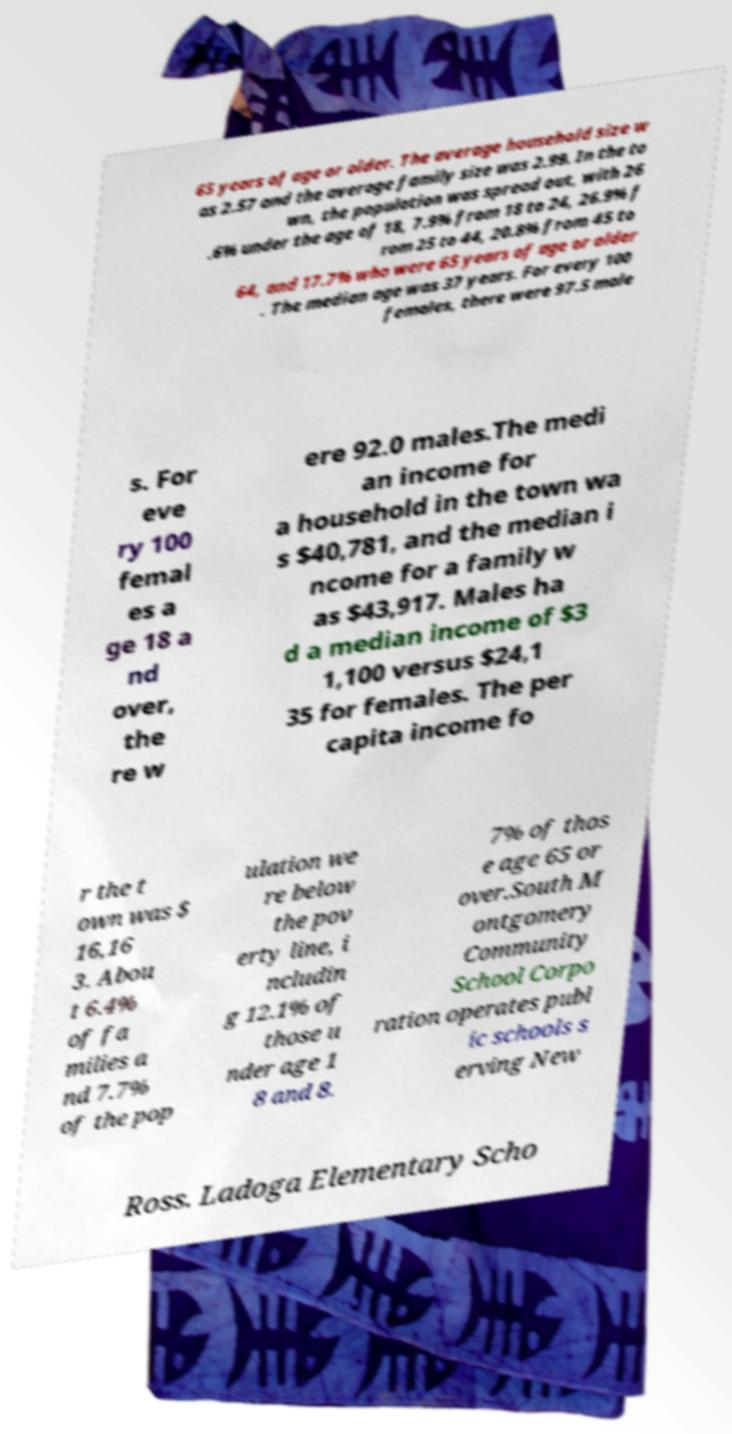What messages or text are displayed in this image? I need them in a readable, typed format. 65 years of age or older. The average household size w as 2.57 and the average family size was 2.99. In the to wn, the population was spread out, with 26 .6% under the age of 18, 7.9% from 18 to 24, 26.9% f rom 25 to 44, 20.8% from 45 to 64, and 17.7% who were 65 years of age or older . The median age was 37 years. For every 100 females, there were 97.5 male s. For eve ry 100 femal es a ge 18 a nd over, the re w ere 92.0 males.The medi an income for a household in the town wa s $40,781, and the median i ncome for a family w as $43,917. Males ha d a median income of $3 1,100 versus $24,1 35 for females. The per capita income fo r the t own was $ 16,16 3. Abou t 6.4% of fa milies a nd 7.7% of the pop ulation we re below the pov erty line, i ncludin g 12.1% of those u nder age 1 8 and 8. 7% of thos e age 65 or over.South M ontgomery Community School Corpo ration operates publ ic schools s erving New Ross. Ladoga Elementary Scho 